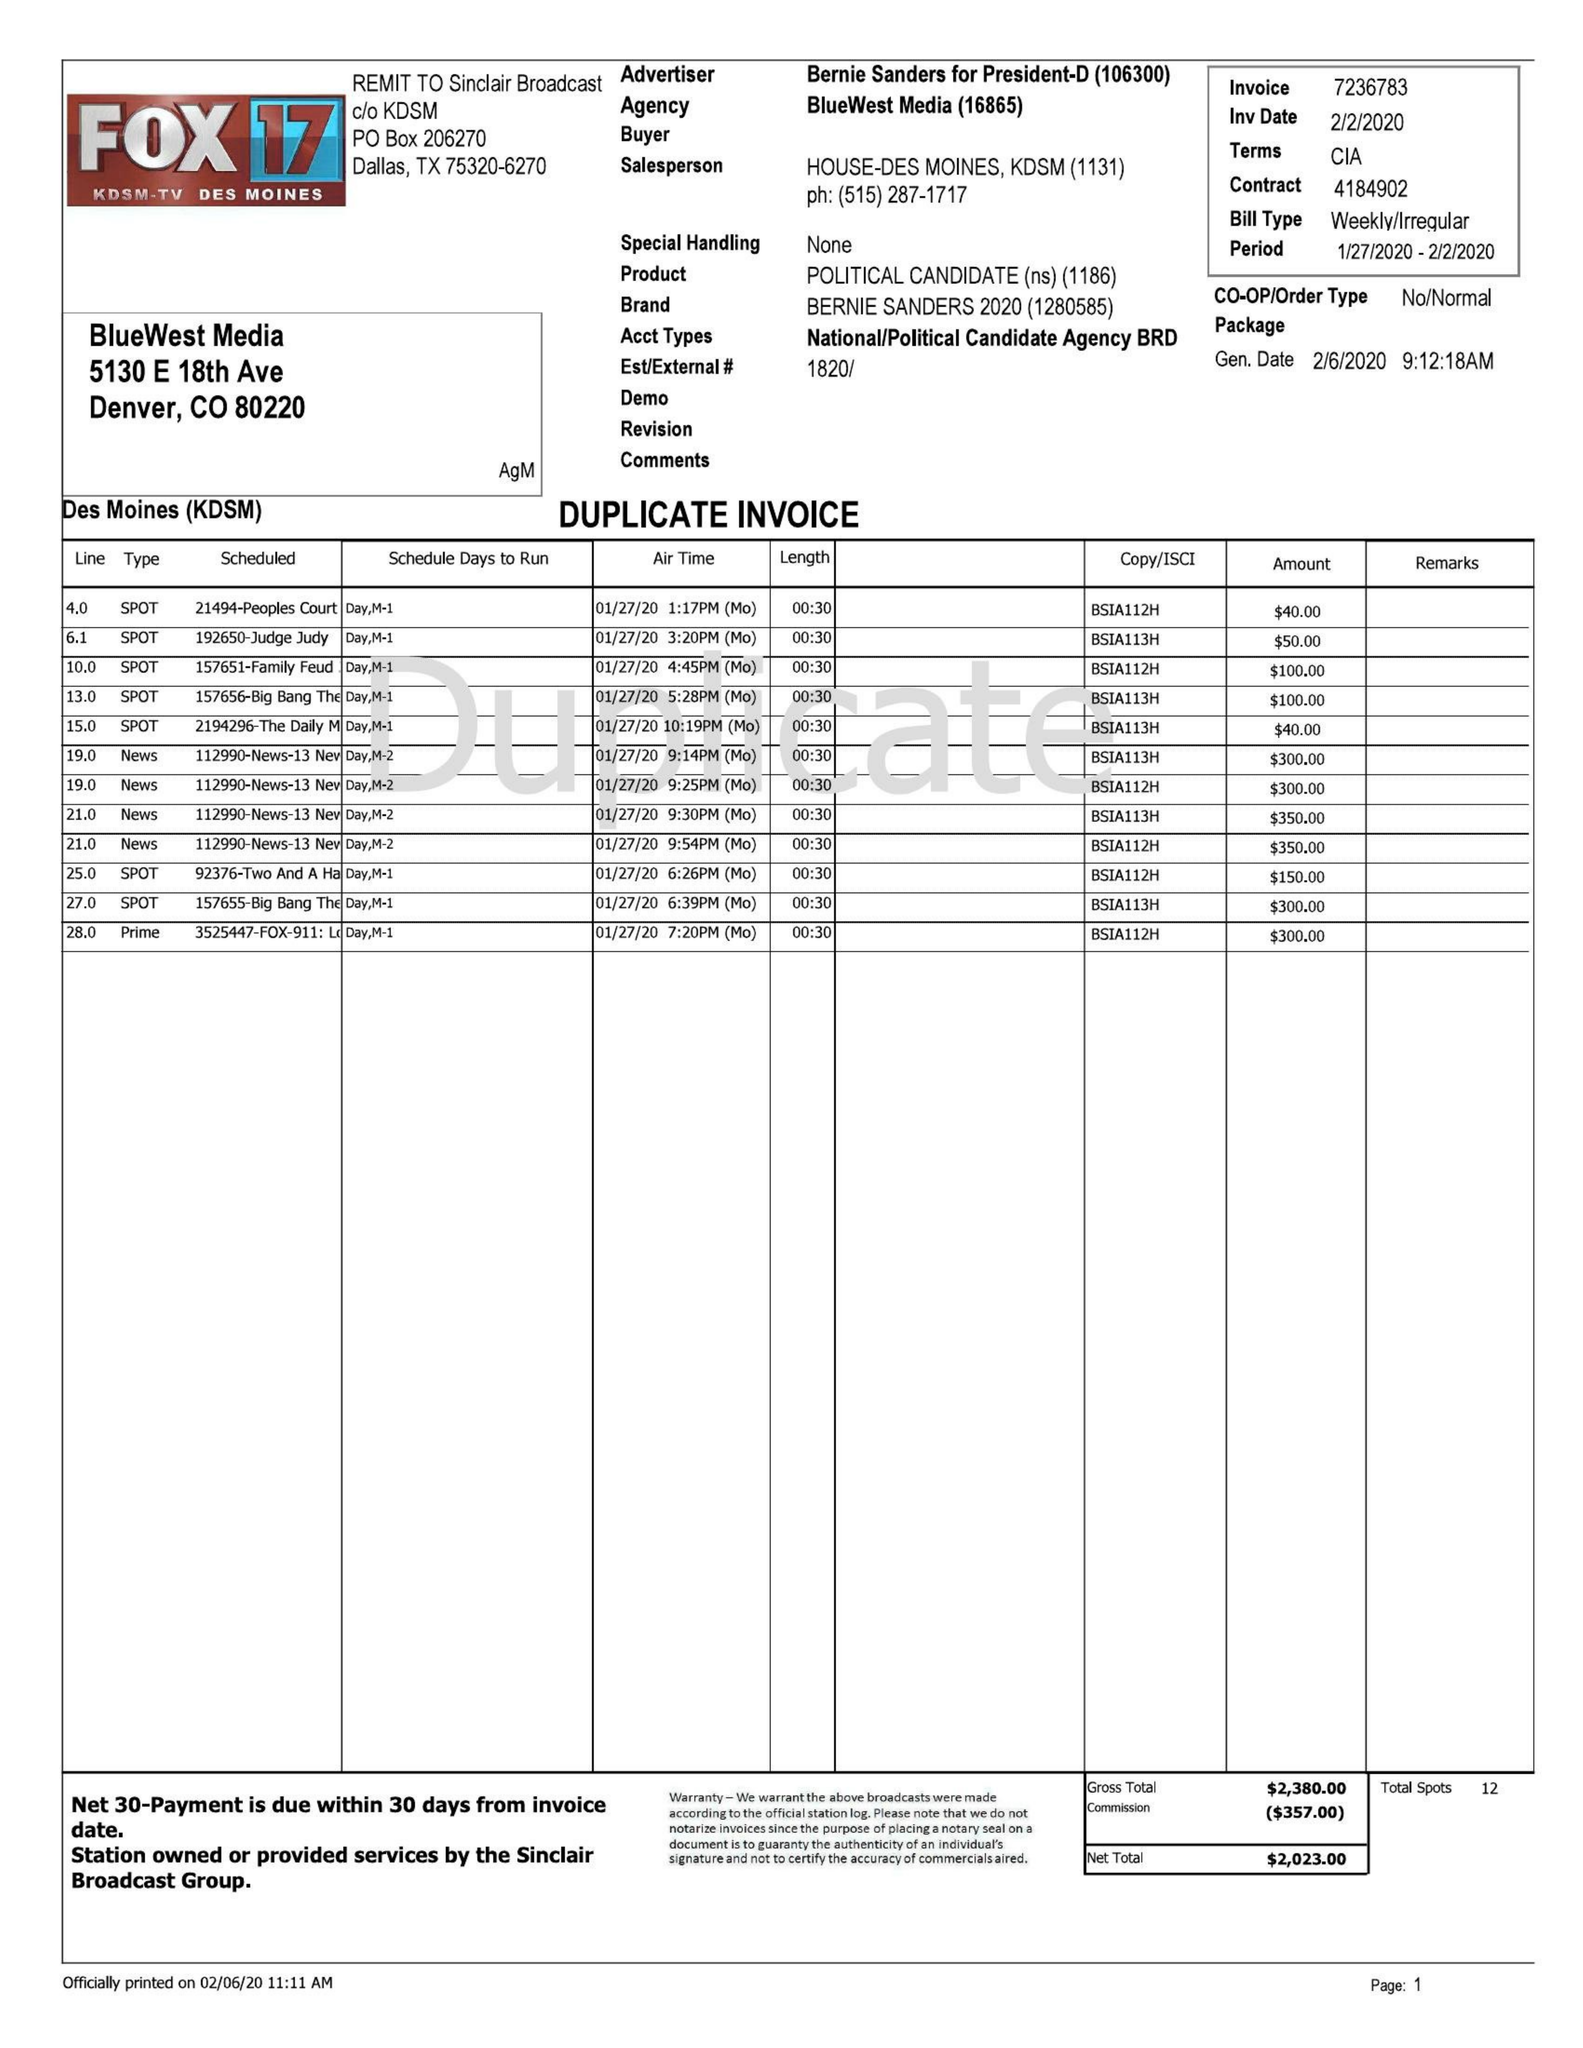What is the value for the gross_amount?
Answer the question using a single word or phrase. 2380.00 